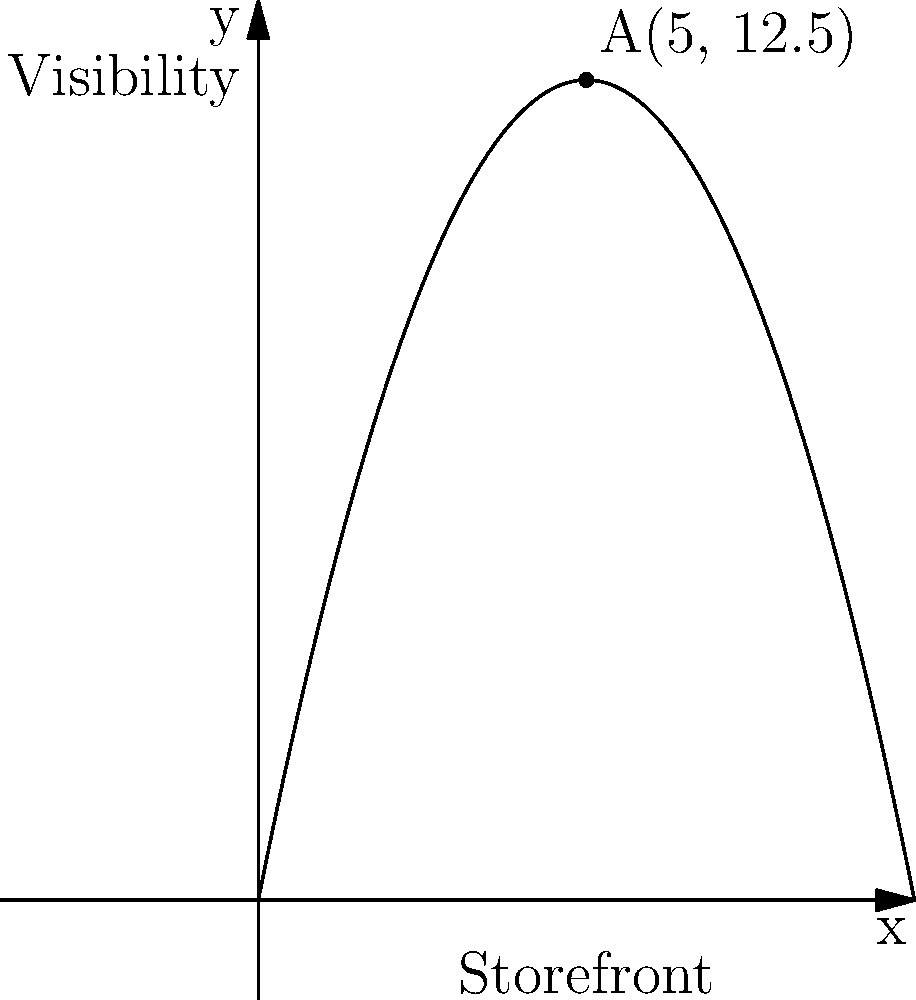You want to place a promotional sign on your restaurant's storefront to maximize visibility. The visibility of the sign can be modeled by the function $f(x) = -0.5x^2 + 5x$, where $x$ represents the horizontal position along the storefront (in meters) and $f(x)$ represents the visibility score. What is the optimal position to place the sign, and what is the maximum visibility score? To find the optimal position and maximum visibility score, we need to follow these steps:

1) The function $f(x) = -0.5x^2 + 5x$ is a quadratic function, which forms a parabola when graphed.

2) The optimal position will be at the vertex of this parabola, where the function reaches its maximum value.

3) For a quadratic function in the form $f(x) = ax^2 + bx + c$, the x-coordinate of the vertex is given by $x = -\frac{b}{2a}$.

4) In our case, $a = -0.5$ and $b = 5$. So:

   $x = -\frac{5}{2(-0.5)} = -\frac{5}{-1} = 5$

5) To find the maximum visibility score, we substitute this x-value back into the original function:

   $f(5) = -0.5(5)^2 + 5(5) = -0.5(25) + 25 = -12.5 + 25 = 12.5$

6) Therefore, the optimal position is 5 meters along the storefront, and the maximum visibility score is 12.5.
Answer: Optimal position: 5 meters; Maximum visibility score: 12.5 